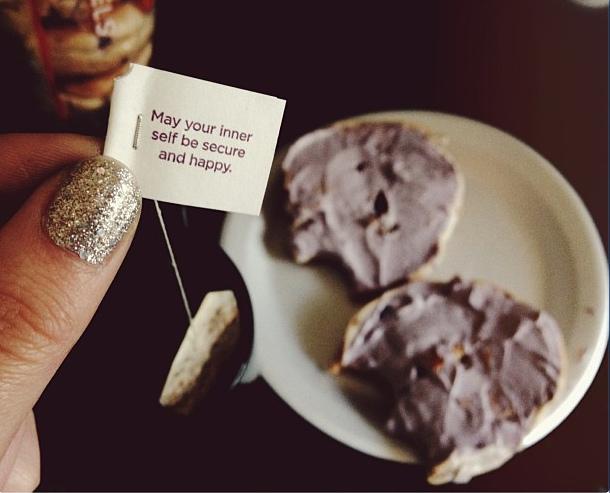What is the message attached to?
Short answer required. Tea bag. Does the donut have a bite out of it?
Quick response, please. Yes. What is meant by "the inner self" in this message?
Be succinct. Your soul. Is this a tea package?
Give a very brief answer. Yes. What food is on the plate?
Give a very brief answer. Bagel. 